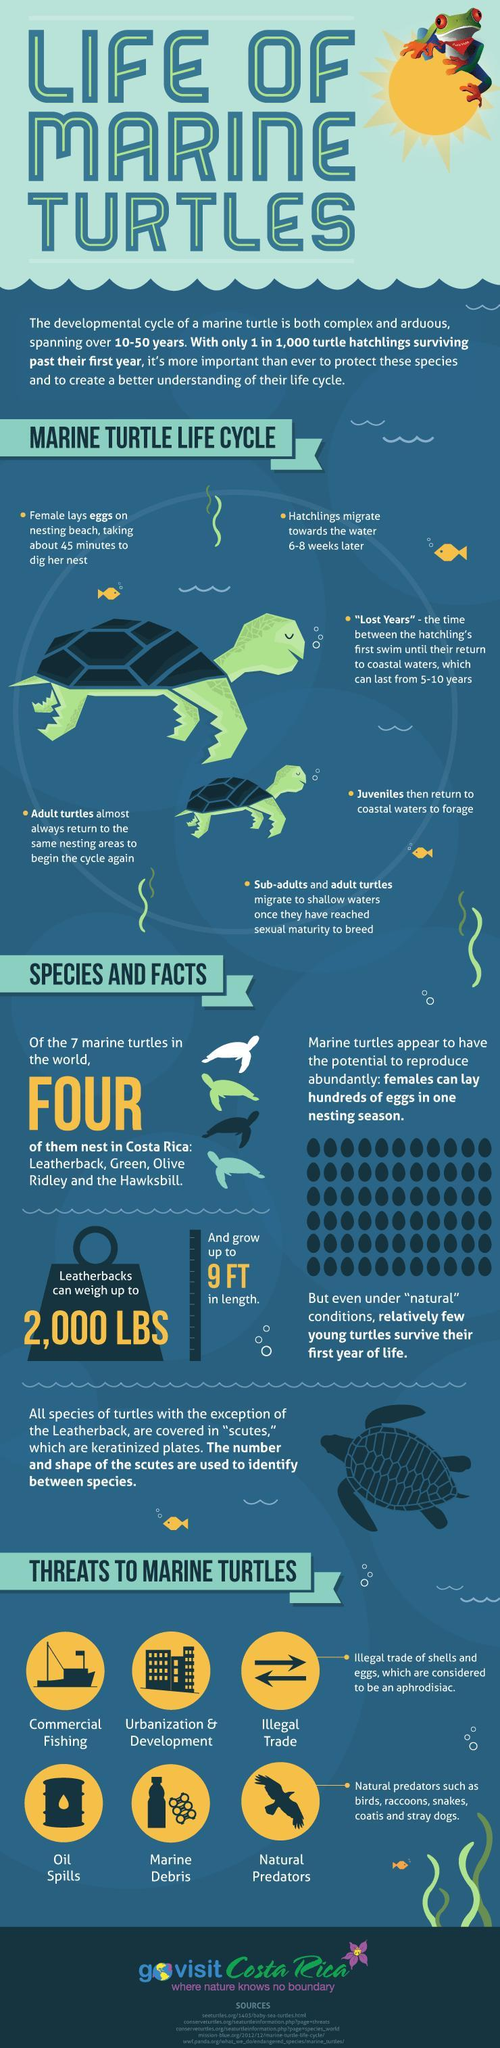What is the maximum length of the Leatherback turtles?
Answer the question with a short phrase. 9 FT How many species of marine turtle are there in the world? 7 What is the maximum weight of the Leatherback turtles? 2,000 LBS What are the three species of marine turtles that live in Costa Rica other than the Hawksbill? Leatherback, Green, Olive Ridley 